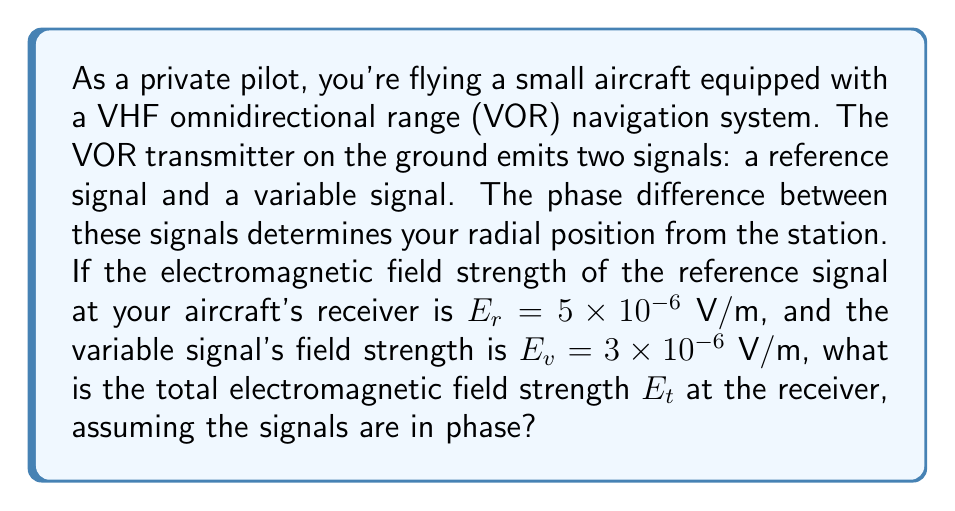Could you help me with this problem? To solve this problem, we'll follow these steps:

1) In electromagnetic field theory, when two waves are in phase, their field strengths add linearly. This is analogous to the Methodist principle of working together in harmony for a greater good.

2) The total field strength $E_t$ is the sum of the reference signal $E_r$ and the variable signal $E_v$:

   $$E_t = E_r + E_v$$

3) Substituting the given values:

   $$E_t = (5 \times 10^{-6}) + (3 \times 10^{-6})$$ V/m

4) Combining like terms:

   $$E_t = 8 \times 10^{-6}$$ V/m

5) This result represents the total electromagnetic field strength at the aircraft's receiver when the signals are in phase.
Answer: $8 \times 10^{-6}$ V/m 